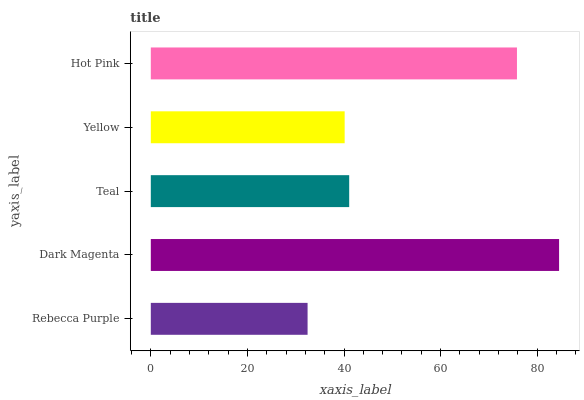Is Rebecca Purple the minimum?
Answer yes or no. Yes. Is Dark Magenta the maximum?
Answer yes or no. Yes. Is Teal the minimum?
Answer yes or no. No. Is Teal the maximum?
Answer yes or no. No. Is Dark Magenta greater than Teal?
Answer yes or no. Yes. Is Teal less than Dark Magenta?
Answer yes or no. Yes. Is Teal greater than Dark Magenta?
Answer yes or no. No. Is Dark Magenta less than Teal?
Answer yes or no. No. Is Teal the high median?
Answer yes or no. Yes. Is Teal the low median?
Answer yes or no. Yes. Is Dark Magenta the high median?
Answer yes or no. No. Is Dark Magenta the low median?
Answer yes or no. No. 